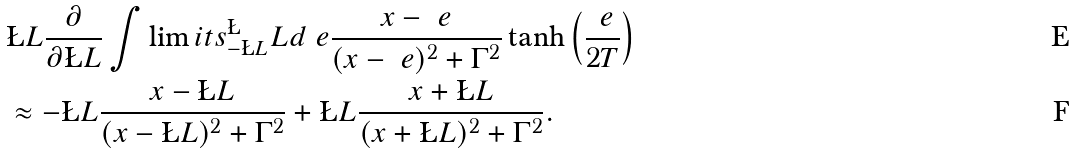<formula> <loc_0><loc_0><loc_500><loc_500>& \L L \frac { \partial } { \partial \L L } \int \lim i t s _ { - \L L } ^ { \L } L d \ e \frac { x - \ e } { ( x - \ e ) ^ { 2 } + \Gamma ^ { 2 } } \tanh \left ( \frac { \ e } { 2 T } \right ) \\ & \approx - \L L \frac { x - \L L } { ( x - \L L ) ^ { 2 } + \Gamma ^ { 2 } } + \L L \frac { x + \L L } { ( x + \L L ) ^ { 2 } + \Gamma ^ { 2 } } .</formula> 